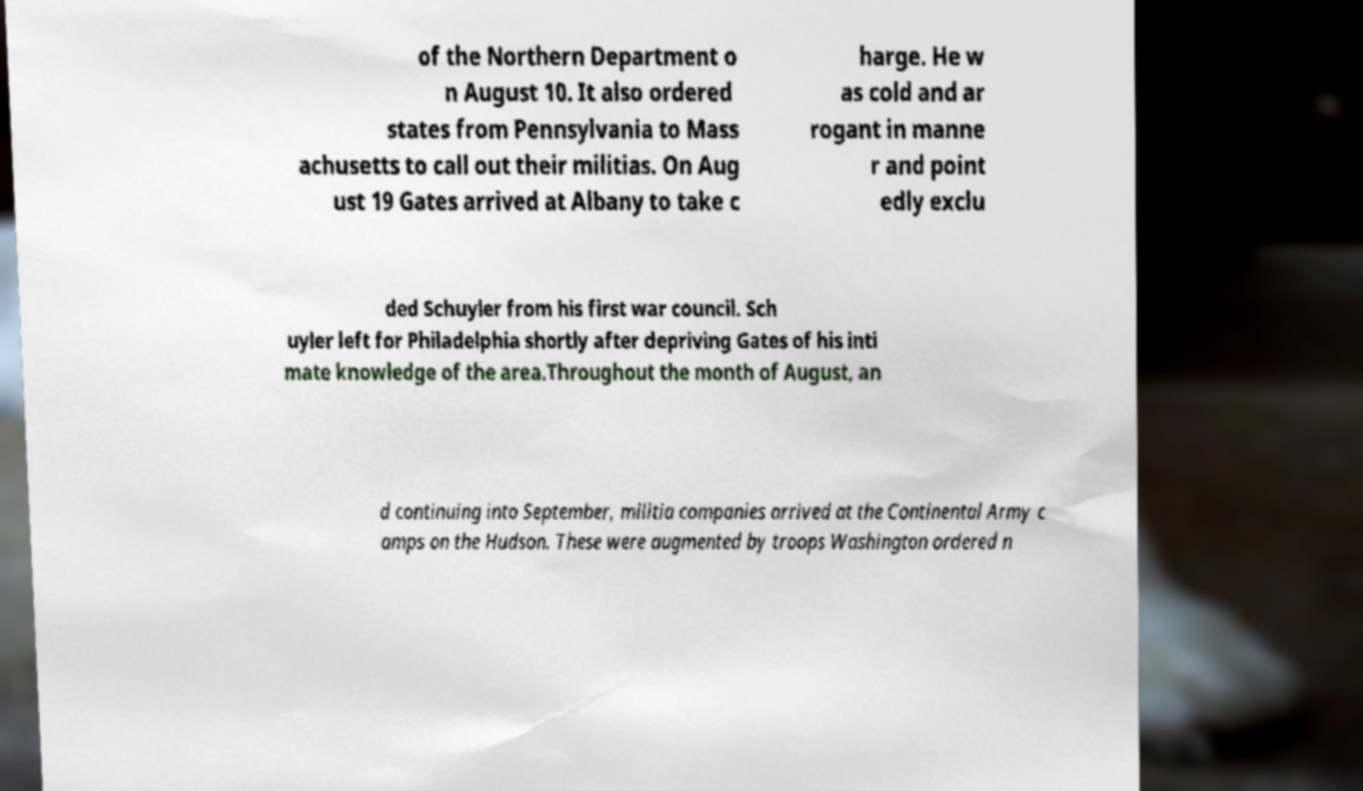There's text embedded in this image that I need extracted. Can you transcribe it verbatim? of the Northern Department o n August 10. It also ordered states from Pennsylvania to Mass achusetts to call out their militias. On Aug ust 19 Gates arrived at Albany to take c harge. He w as cold and ar rogant in manne r and point edly exclu ded Schuyler from his first war council. Sch uyler left for Philadelphia shortly after depriving Gates of his inti mate knowledge of the area.Throughout the month of August, an d continuing into September, militia companies arrived at the Continental Army c amps on the Hudson. These were augmented by troops Washington ordered n 